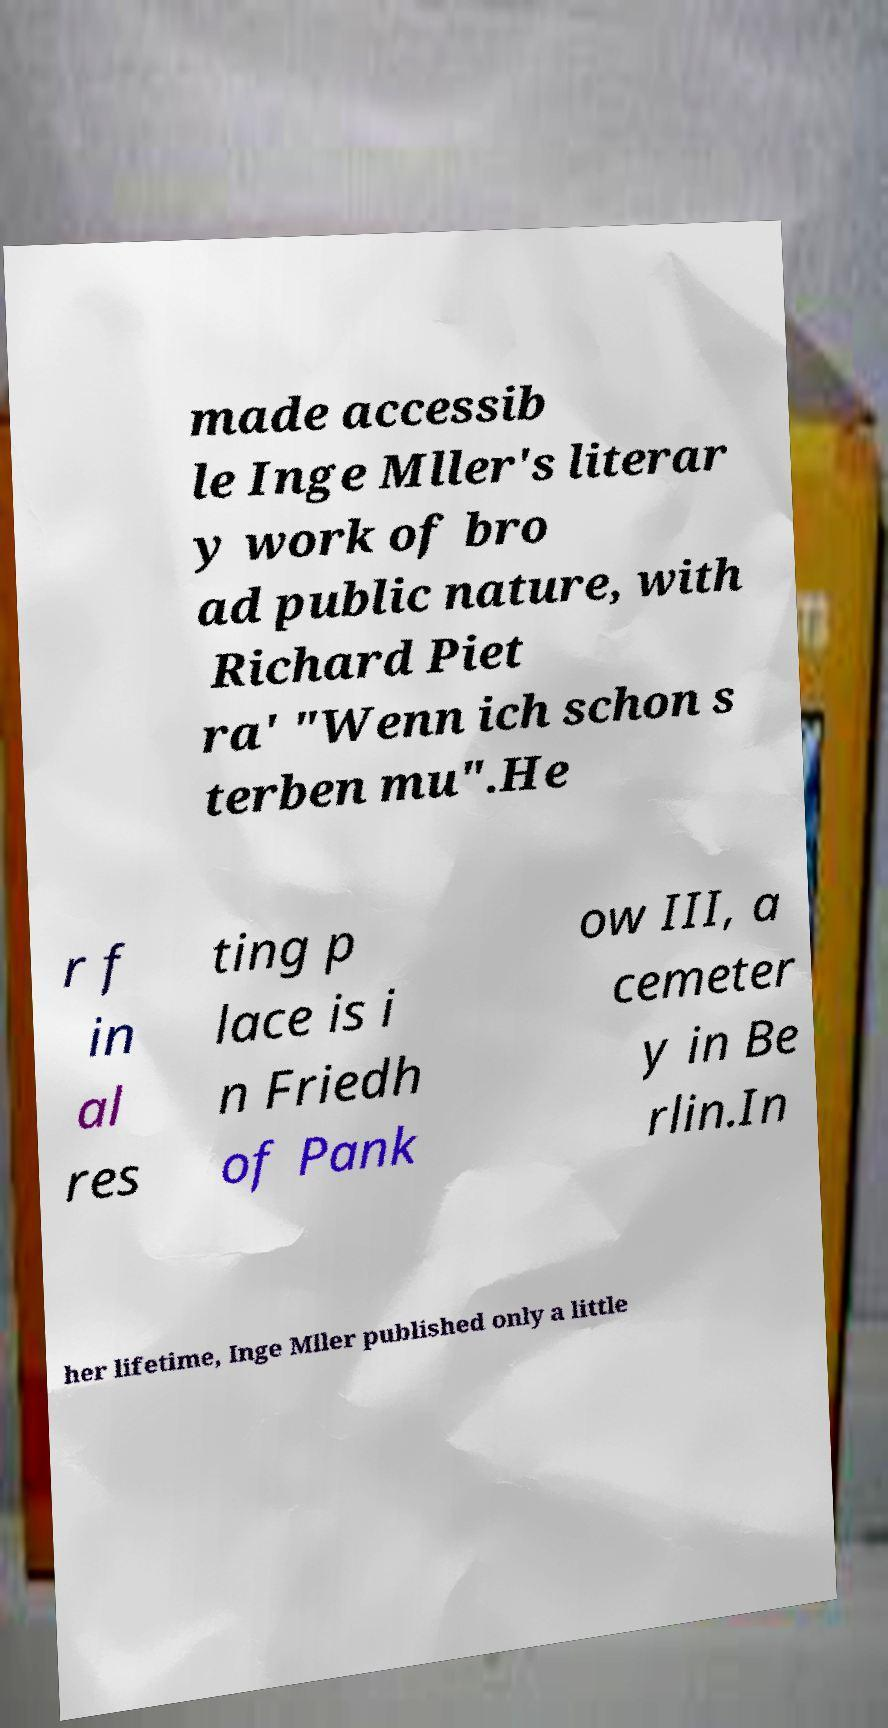What messages or text are displayed in this image? I need them in a readable, typed format. made accessib le Inge Mller's literar y work of bro ad public nature, with Richard Piet ra' "Wenn ich schon s terben mu".He r f in al res ting p lace is i n Friedh of Pank ow III, a cemeter y in Be rlin.In her lifetime, Inge Mller published only a little 